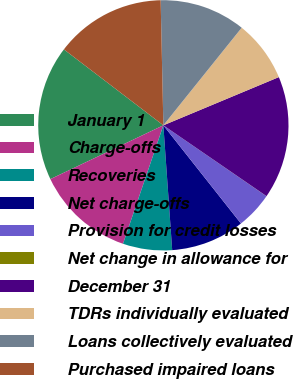Convert chart. <chart><loc_0><loc_0><loc_500><loc_500><pie_chart><fcel>January 1<fcel>Charge-offs<fcel>Recoveries<fcel>Net charge-offs<fcel>Provision for credit losses<fcel>Net change in allowance for<fcel>December 31<fcel>TDRs individually evaluated<fcel>Loans collectively evaluated<fcel>Purchased impaired loans<nl><fcel>17.45%<fcel>12.7%<fcel>6.35%<fcel>9.52%<fcel>4.77%<fcel>0.01%<fcel>15.87%<fcel>7.94%<fcel>11.11%<fcel>14.28%<nl></chart> 